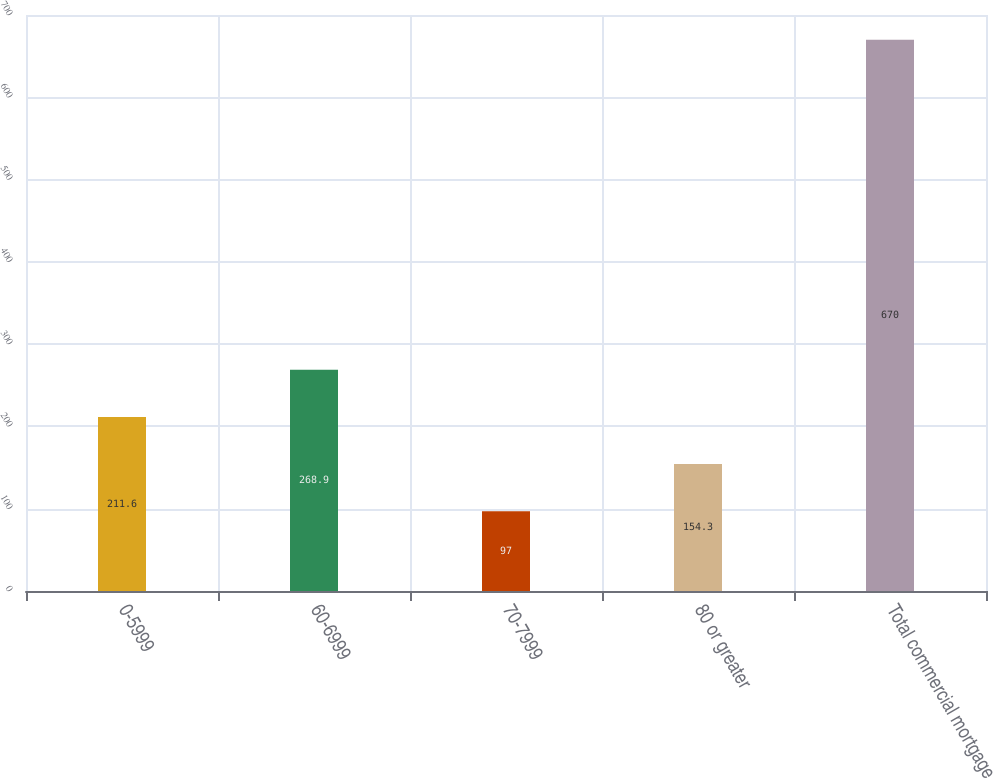Convert chart to OTSL. <chart><loc_0><loc_0><loc_500><loc_500><bar_chart><fcel>0-5999<fcel>60-6999<fcel>70-7999<fcel>80 or greater<fcel>Total commercial mortgage<nl><fcel>211.6<fcel>268.9<fcel>97<fcel>154.3<fcel>670<nl></chart> 